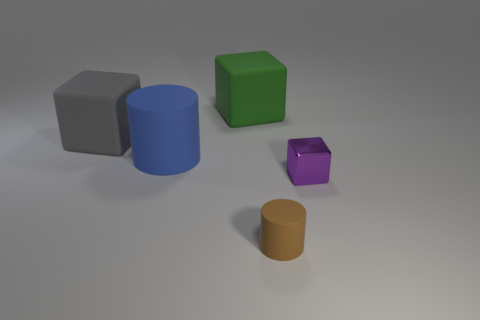What number of things are big gray objects or rubber blocks on the left side of the large blue object? The left side of the large blue cylindrical object features one big gray object, which appears to be a gray cube. 